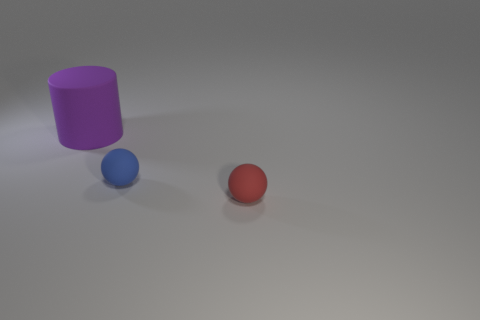What size is the cylinder that is made of the same material as the blue thing?
Offer a terse response. Large. Are there any big rubber objects that have the same color as the large rubber cylinder?
Your answer should be compact. No. How many objects are small red things or tiny things to the right of the blue thing?
Ensure brevity in your answer.  1. Is the number of large red rubber things greater than the number of tiny blue spheres?
Give a very brief answer. No. Are there any small blue objects made of the same material as the red ball?
Give a very brief answer. Yes. There is a matte thing that is both on the right side of the big thing and on the left side of the red object; what shape is it?
Make the answer very short. Sphere. What number of other things are there of the same shape as the big purple thing?
Offer a very short reply. 0. How big is the blue matte object?
Your answer should be compact. Small. How many objects are big red things or red spheres?
Keep it short and to the point. 1. There is a object that is to the right of the tiny blue sphere; how big is it?
Provide a succinct answer. Small. 